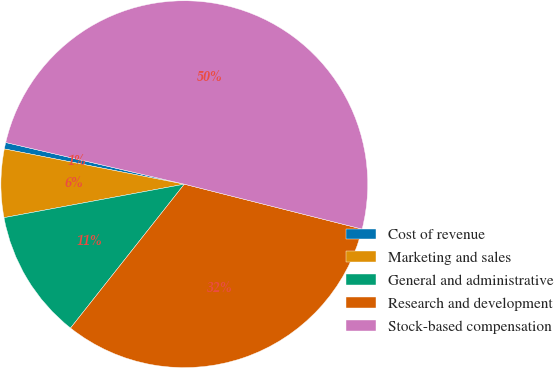<chart> <loc_0><loc_0><loc_500><loc_500><pie_chart><fcel>Cost of revenue<fcel>Marketing and sales<fcel>General and administrative<fcel>Research and development<fcel>Stock-based compensation<nl><fcel>0.57%<fcel>6.0%<fcel>11.43%<fcel>31.71%<fcel>50.29%<nl></chart> 